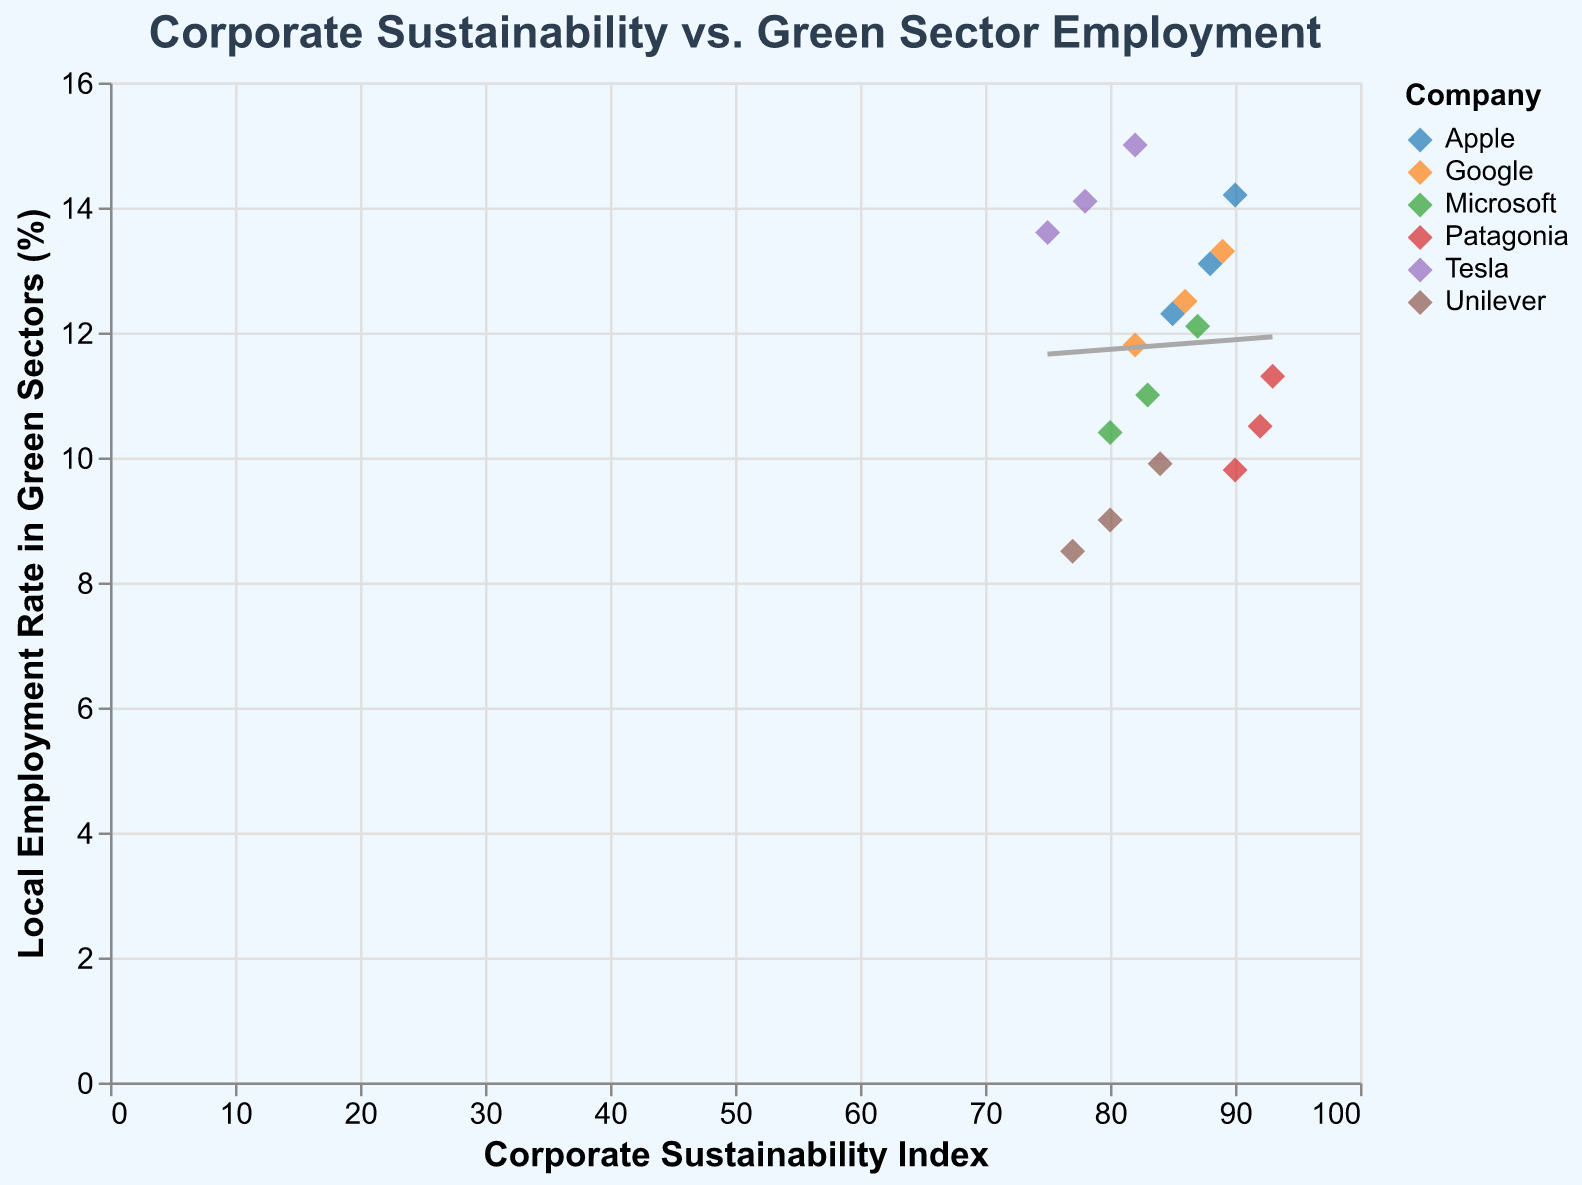What's the title of the plot? The title is displayed at the top center of the plot. It reads "Corporate Sustainability vs. Green Sector Employment".
Answer: Corporate Sustainability vs. Green Sector Employment Which company has the highest Corporate Sustainability Index in 2021? By looking at the tooltip information for each point related to the year 2021, Patagonia has the highest Corporate Sustainability Index in 2021 at 93.
Answer: Patagonia What is the Local Employment Rate in Green Sectors for Unilever in 2019? By hovering over the data point for Unilever in the tooltip, it's indicated that the Local Employment Rate in Green Sectors for Unilever in 2019 is 8.5%.
Answer: 8.5% How does Tesla's Corporate Sustainability Index change from 2019 to 2021? In 2019, Tesla's Corporate Sustainability Index is 75. In 2020, it increases to 78, and in 2021, it rises to 82. The change from 2019 to 2021 is 82 - 75 = 7.
Answer: 7 Which companies show an increase in their Local Employment Rate in Green Sectors from 2020 to 2021? By comparing the Local Employment Rate in Green Sectors for each company between 2020 and 2021, all companies (Apple, Google, Microsoft, Tesla, Patagonia, Unilever) show an increase.
Answer: Apple, Google, Microsoft, Tesla, Patagonia, Unilever Compare the Local Employment Rate in Green Sectors of Google and Microsoft in 2021. Which company has a higher rate? For 2021, Google's Local Employment Rate in Green Sectors is 13.3% and Microsoft's is 12.1%. Thus, Google has a higher rate.
Answer: Google Which company has the lowest Local Employment Rate in Green Sectors in 2019? By examining the tooltip data for 2019, the company with the lowest rate is Unilever, with a Local Employment Rate in Green Sectors of 8.5%.
Answer: Unilever Is there a general trend between Corporate Sustainability Index and Local Employment Rate in Green Sectors? The trend line in the scatter plot shows a positive slope, indicating that a higher Corporate Sustainability Index is generally associated with a higher Local Employment Rate in Green Sectors.
Answer: Yes, positive trend 